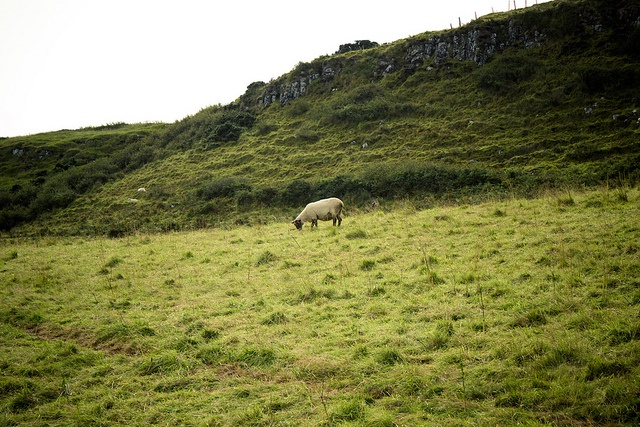Describe the objects in this image and their specific colors. I can see a sheep in white, tan, olive, and black tones in this image. 